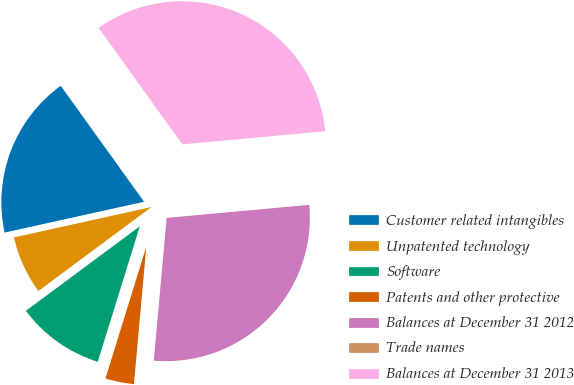<chart> <loc_0><loc_0><loc_500><loc_500><pie_chart><fcel>Customer related intangibles<fcel>Unpatented technology<fcel>Software<fcel>Patents and other protective<fcel>Balances at December 31 2012<fcel>Trade names<fcel>Balances at December 31 2013<nl><fcel>18.54%<fcel>6.7%<fcel>10.05%<fcel>3.36%<fcel>27.88%<fcel>0.01%<fcel>33.46%<nl></chart> 